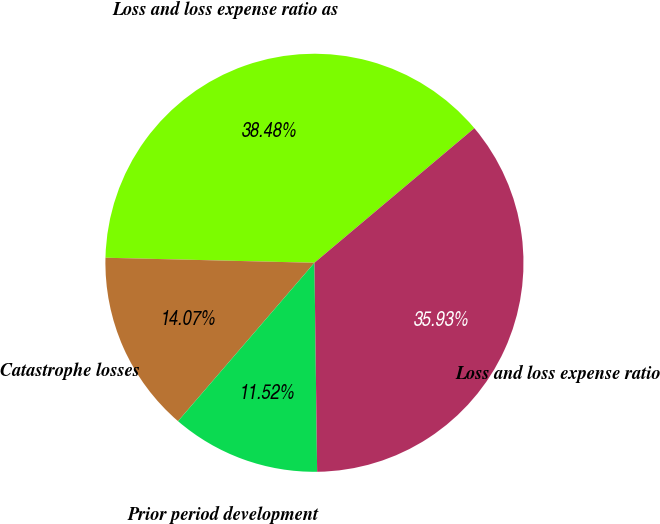Convert chart to OTSL. <chart><loc_0><loc_0><loc_500><loc_500><pie_chart><fcel>Loss and loss expense ratio as<fcel>Catastrophe losses<fcel>Prior period development<fcel>Loss and loss expense ratio<nl><fcel>38.48%<fcel>14.07%<fcel>11.52%<fcel>35.93%<nl></chart> 